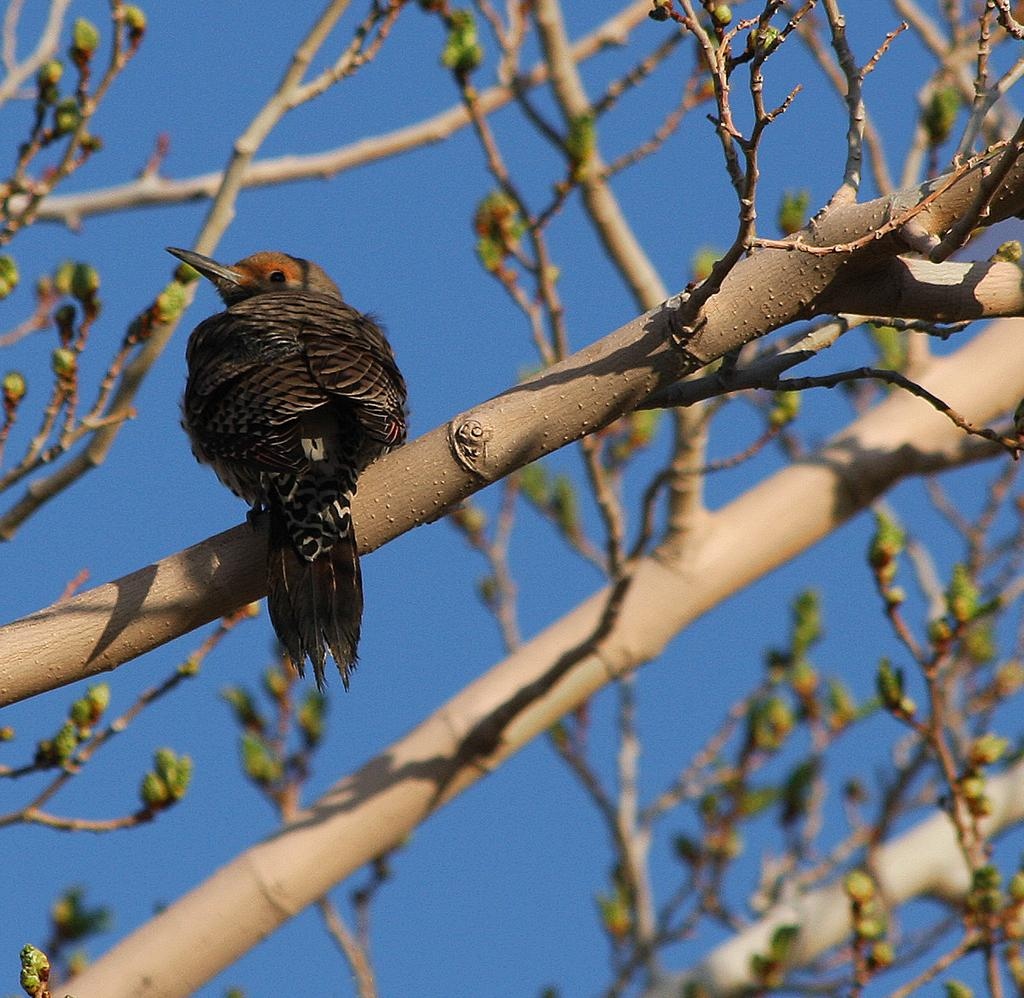What type of animal is present in the image? There is a bird in the image. Where is the bird located in the image? The bird is standing on the branch of a tree. What is visible at the top of the image? The sky is visible at the top of the image. What type of breakfast is the bird eating in the image? There is no indication in the image that the bird is eating any breakfast, so it cannot be determined from the picture. 